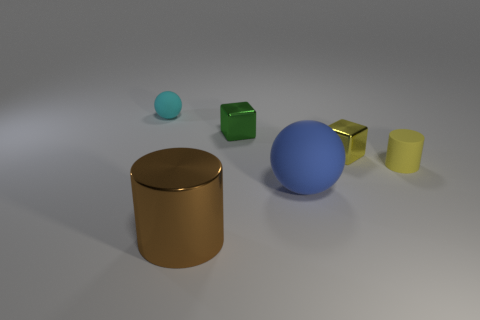What number of other objects are there of the same size as the metal cylinder?
Offer a terse response. 1. There is a cyan ball; are there any tiny green metal things behind it?
Ensure brevity in your answer.  No. Do the large rubber sphere and the sphere left of the big cylinder have the same color?
Your response must be concise. No. The cylinder in front of the ball that is in front of the sphere behind the large blue rubber object is what color?
Your response must be concise. Brown. Is there another big object that has the same shape as the brown metallic object?
Your answer should be very brief. No. There is a cylinder that is the same size as the blue sphere; what color is it?
Give a very brief answer. Brown. What is the large object that is left of the big blue rubber thing made of?
Offer a terse response. Metal. Is the shape of the matte object to the left of the brown cylinder the same as the large object on the right side of the large brown thing?
Offer a terse response. Yes. Are there the same number of large blue matte objects on the right side of the large blue object and large cylinders?
Offer a terse response. No. What number of cylinders are made of the same material as the blue thing?
Offer a very short reply. 1. 